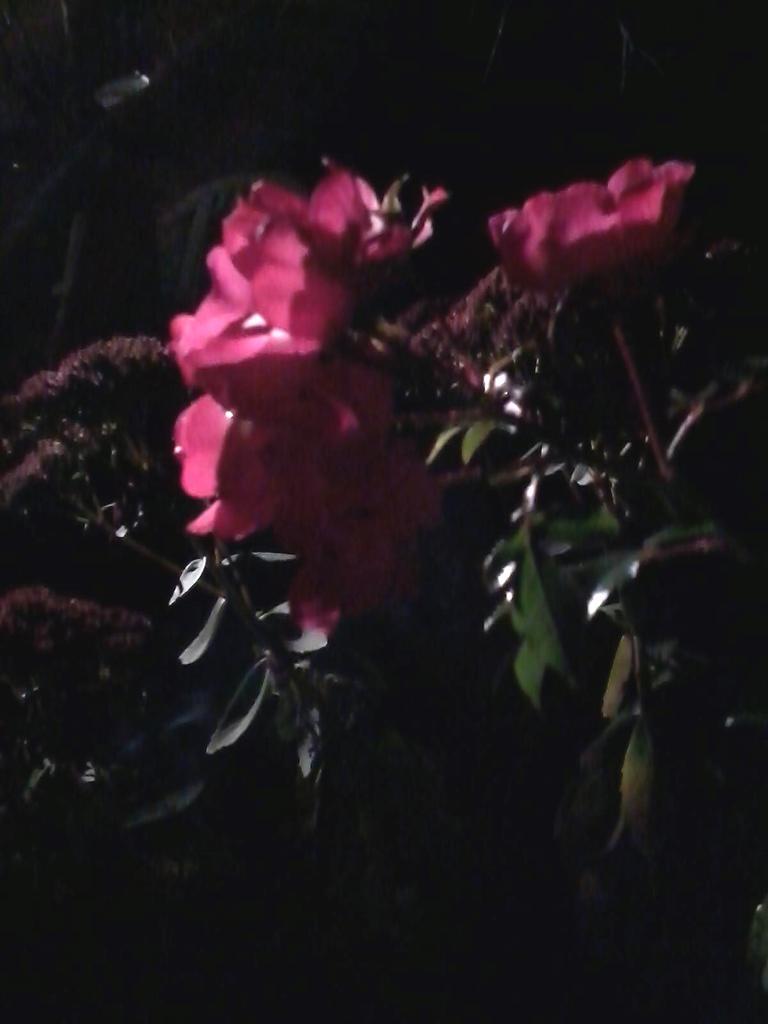Can you describe this image briefly? In this picture we can see plants with flowers and in the background we can see it is dark. 